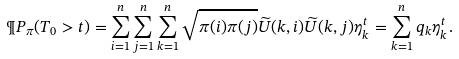Convert formula to latex. <formula><loc_0><loc_0><loc_500><loc_500>\P P _ { \pi } ( T _ { 0 } > t ) = \sum _ { i = 1 } ^ { n } \sum _ { j = 1 } ^ { n } \sum _ { k = 1 } ^ { n } \sqrt { \pi ( i ) \pi ( j ) } \widetilde { U } ( k , i ) \widetilde { U } ( k , j ) \eta _ { k } ^ { t } = \sum _ { k = 1 } ^ { n } q _ { k } \eta _ { k } ^ { t } .</formula> 